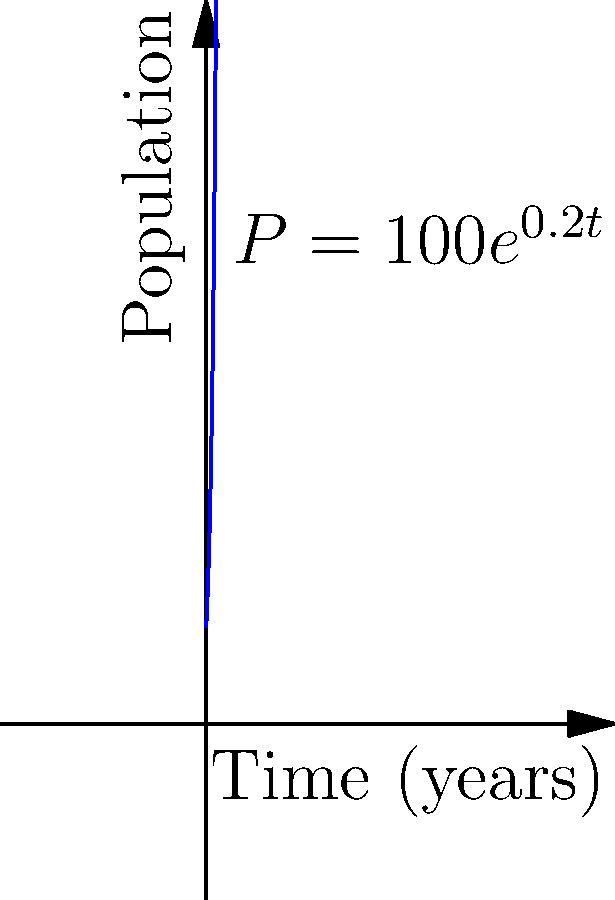A native Australian plant species, traditionally used by Aboriginal communities for medicinal purposes, is being reintroduced to its natural habitat. The population growth of this species can be modeled by the function $P(t) = 100e^{0.2t}$, where $P$ is the population and $t$ is the time in years. How many years will it take for the population to reach 1000 plants? To solve this problem, we need to follow these steps:

1) We start with the equation: $P(t) = 100e^{0.2t}$

2) We want to find $t$ when $P(t) = 1000$. So, let's substitute this:

   $1000 = 100e^{0.2t}$

3) Divide both sides by 100:

   $10 = e^{0.2t}$

4) Take the natural logarithm of both sides:

   $\ln(10) = \ln(e^{0.2t})$

5) Simplify the right side using the properties of logarithms:

   $\ln(10) = 0.2t$

6) Divide both sides by 0.2:

   $\frac{\ln(10)}{0.2} = t$

7) Calculate the value:

   $t \approx 11.51$ years

Therefore, it will take approximately 11.51 years for the population to reach 1000 plants.
Answer: 11.51 years 